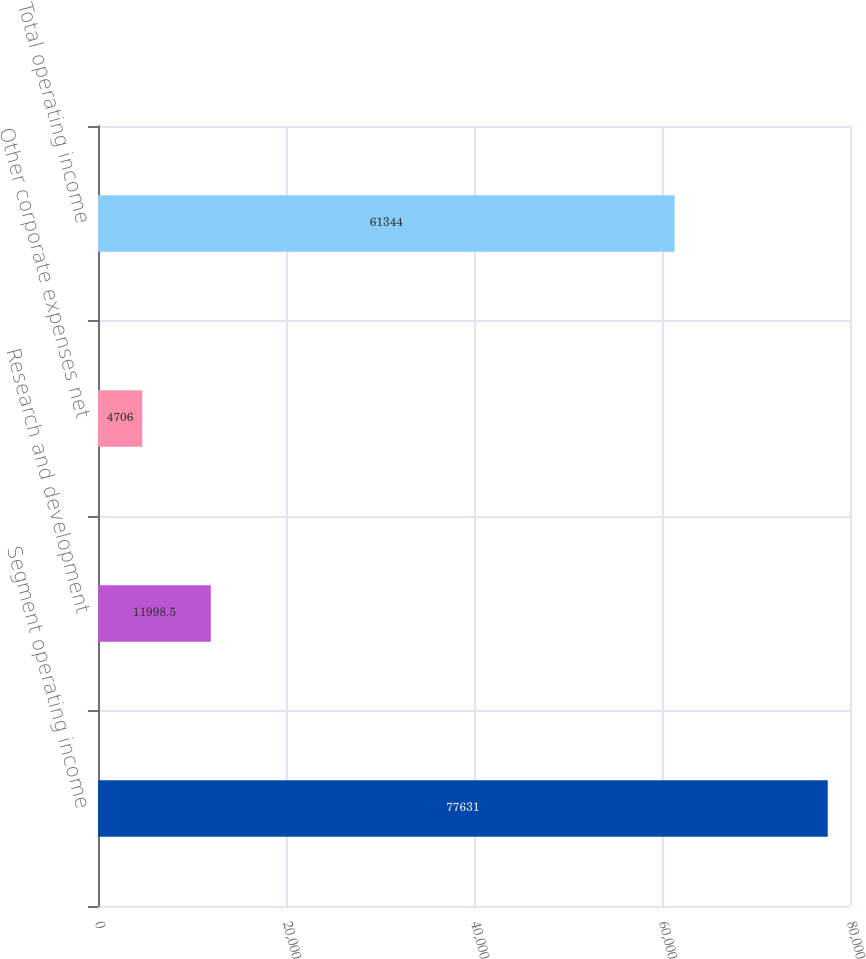Convert chart. <chart><loc_0><loc_0><loc_500><loc_500><bar_chart><fcel>Segment operating income<fcel>Research and development<fcel>Other corporate expenses net<fcel>Total operating income<nl><fcel>77631<fcel>11998.5<fcel>4706<fcel>61344<nl></chart> 